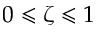<formula> <loc_0><loc_0><loc_500><loc_500>0 \leqslant \zeta \leqslant 1</formula> 